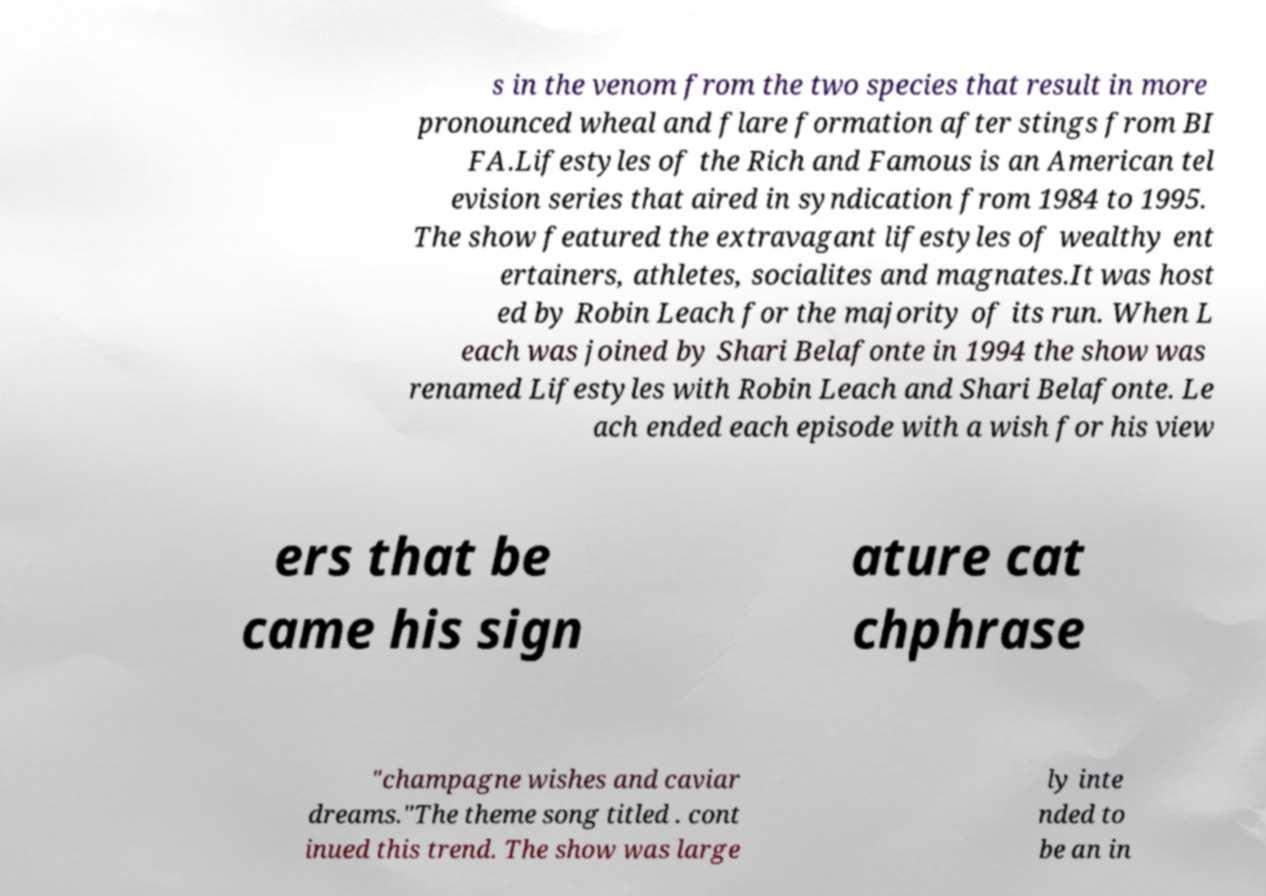Could you assist in decoding the text presented in this image and type it out clearly? s in the venom from the two species that result in more pronounced wheal and flare formation after stings from BI FA.Lifestyles of the Rich and Famous is an American tel evision series that aired in syndication from 1984 to 1995. The show featured the extravagant lifestyles of wealthy ent ertainers, athletes, socialites and magnates.It was host ed by Robin Leach for the majority of its run. When L each was joined by Shari Belafonte in 1994 the show was renamed Lifestyles with Robin Leach and Shari Belafonte. Le ach ended each episode with a wish for his view ers that be came his sign ature cat chphrase "champagne wishes and caviar dreams."The theme song titled . cont inued this trend. The show was large ly inte nded to be an in 